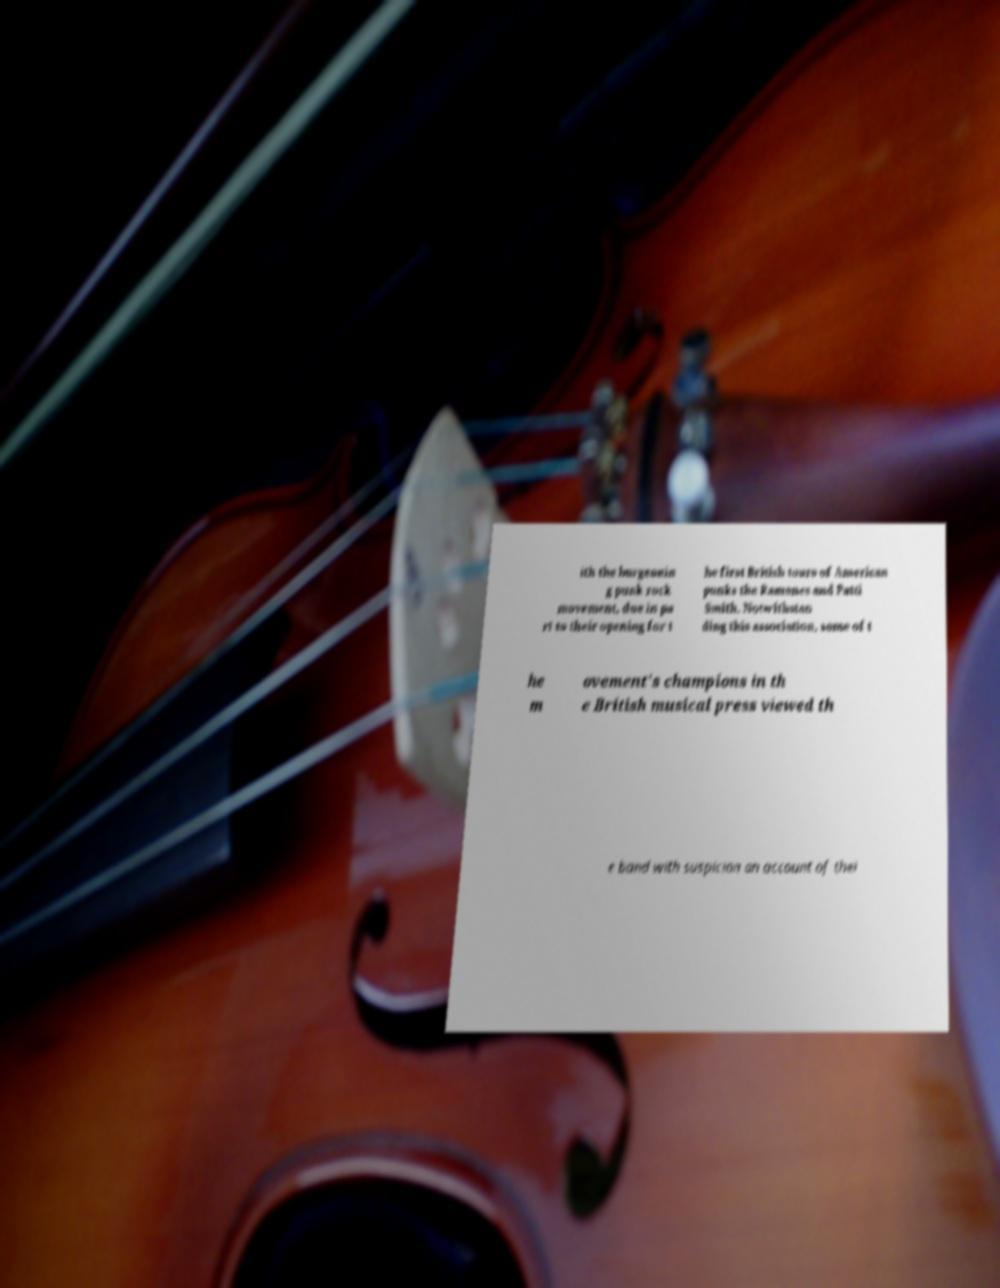Could you assist in decoding the text presented in this image and type it out clearly? ith the burgeonin g punk rock movement, due in pa rt to their opening for t he first British tours of American punks the Ramones and Patti Smith. Notwithstan ding this association, some of t he m ovement's champions in th e British musical press viewed th e band with suspicion on account of thei 